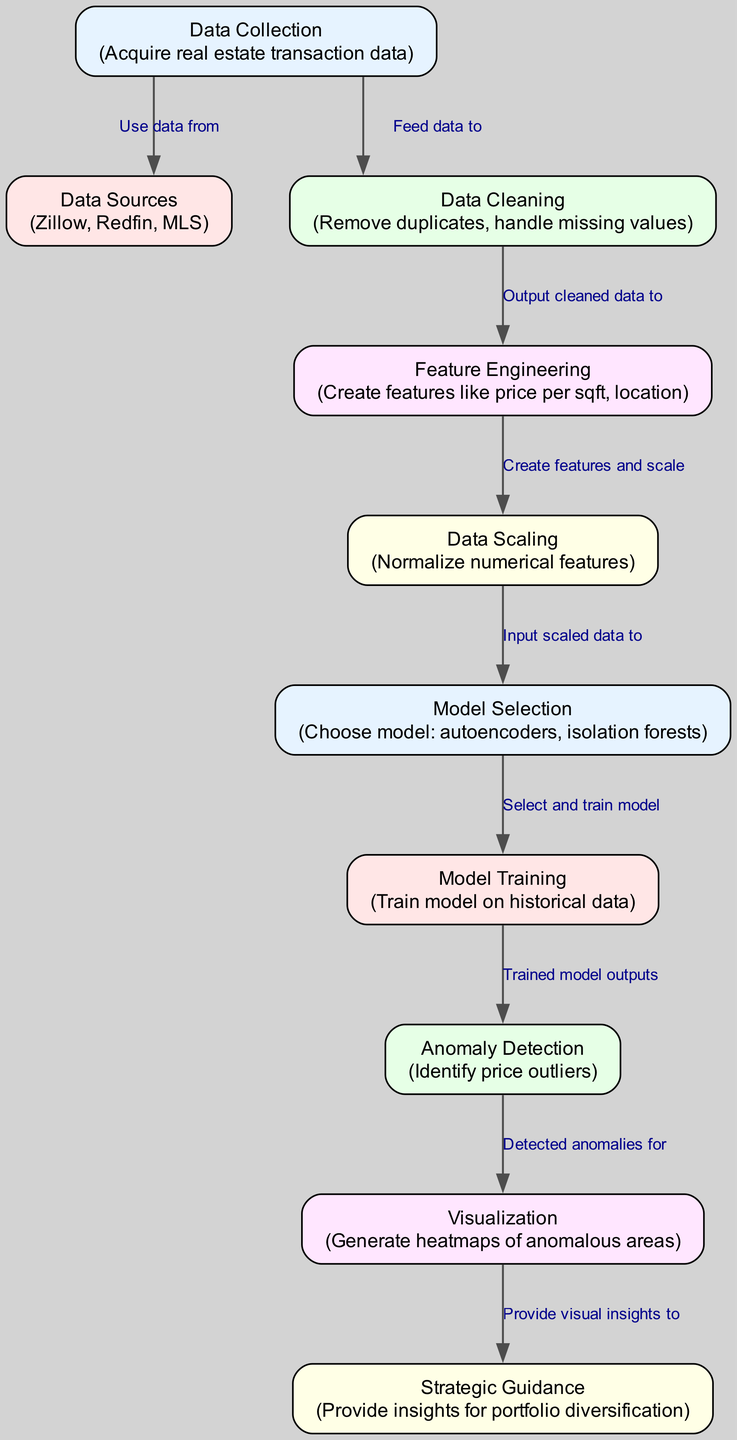What is the first step in the diagram? The first step shown in the diagram is "Data Collection." It is the initial node that begins the flow of the processes leading to anomaly detection in real estate prices.
Answer: Data Collection How many nodes are present in the diagram? Counting each unique box or entity represented in the diagram, there are a total of ten nodes involved in the process.
Answer: Ten What model is used for anomaly detection? The diagram indicates that the models selected for anomaly detection include autoencoders and isolation forests, both of which are noted in the "Model Selection" node.
Answer: Autoencoders, isolation forests What does the "Visualization" node feed into? The "Visualization" node outputs insights to the "Strategic Guidance" node, indicating that the visual insights are used for providing strategic advice.
Answer: Strategic Guidance Which node directly follows "Model Training"? The node that directly follows "Model Training" in the sequence is "Anomaly Detection," illustrating the progression from training the model to detecting anomalies.
Answer: Anomaly Detection What kind of data sources are mentioned in the diagram? The diagram lists specific data sources used for real estate analysis, namely Zillow, Redfin, and MLS, categorized under the "Data Sources" node.
Answer: Zillow, Redfin, MLS After "Data Scaling," which process comes next? The flow from "Data Scaling" directly leads to "Model Selection," showing that the scaled data is what informs the choice of model for anomaly detection.
Answer: Model Selection What is the purpose of feature engineering in the process? The "Feature Engineering" step is responsible for creating features like price per square foot and location, which are essential for meaningful analysis in the subsequent steps.
Answer: Create features What is indicated by the "Anomaly Detection" node? The "Anomaly Detection" node indicates that the process aims to identify price outliers, which is directly linked to the purpose of the overall diagram focused on detecting anomalies.
Answer: Identify price outliers Which step involves cleaning the data? The step that involves cleaning the data is called "Data Cleaning," which is crucial for preparing the data by removing duplicates and handling missing values before further processing.
Answer: Data Cleaning 